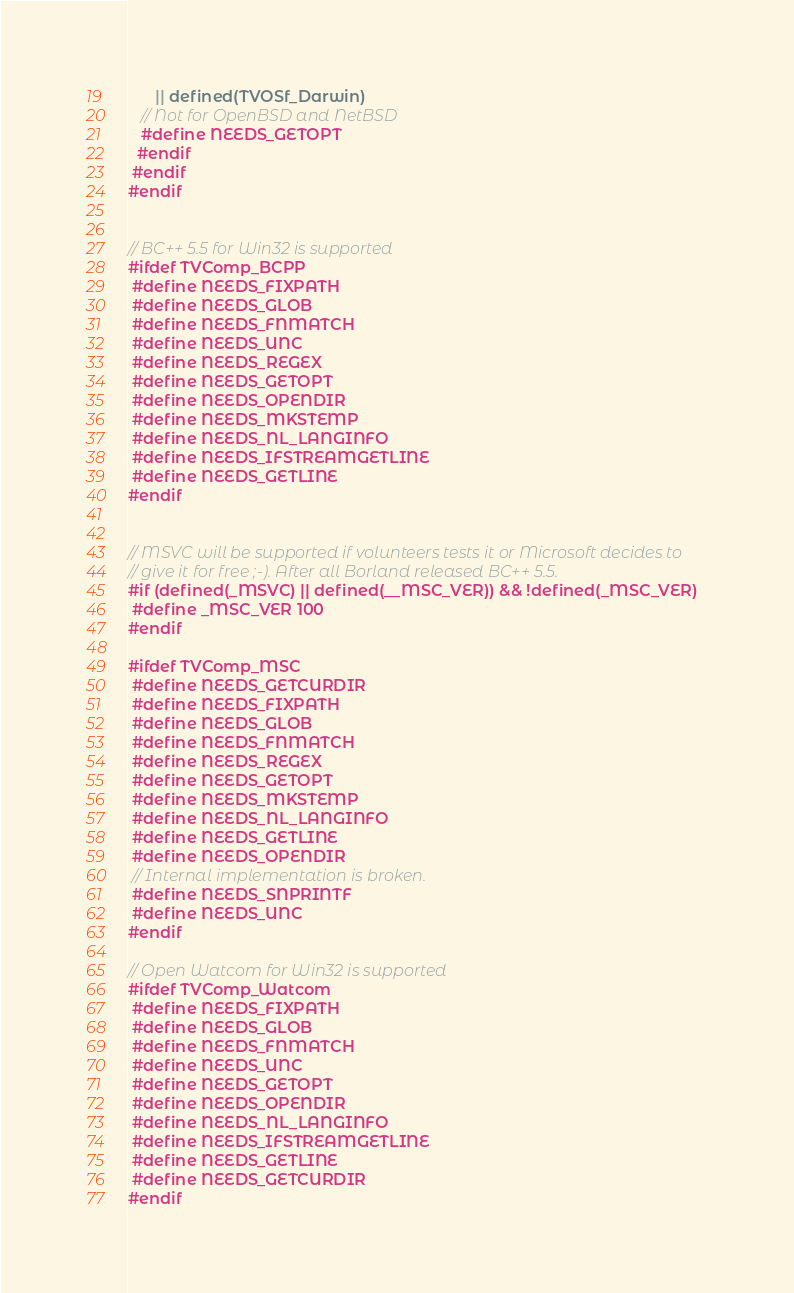Convert code to text. <code><loc_0><loc_0><loc_500><loc_500><_C_>      || defined(TVOSf_Darwin)
   // Not for OpenBSD and NetBSD
   #define NEEDS_GETOPT
  #endif
 #endif
#endif


// BC++ 5.5 for Win32 is supported
#ifdef TVComp_BCPP
 #define NEEDS_FIXPATH
 #define NEEDS_GLOB
 #define NEEDS_FNMATCH
 #define NEEDS_UNC
 #define NEEDS_REGEX
 #define NEEDS_GETOPT
 #define NEEDS_OPENDIR
 #define NEEDS_MKSTEMP
 #define NEEDS_NL_LANGINFO
 #define NEEDS_IFSTREAMGETLINE
 #define NEEDS_GETLINE
#endif


// MSVC will be supported if volunteers tests it or Microsoft decides to
// give it for free ;-). After all Borland released BC++ 5.5.
#if (defined(_MSVC) || defined(__MSC_VER)) && !defined(_MSC_VER)
 #define _MSC_VER 100
#endif

#ifdef TVComp_MSC
 #define NEEDS_GETCURDIR
 #define NEEDS_FIXPATH
 #define NEEDS_GLOB
 #define NEEDS_FNMATCH
 #define NEEDS_REGEX
 #define NEEDS_GETOPT
 #define NEEDS_MKSTEMP
 #define NEEDS_NL_LANGINFO
 #define NEEDS_GETLINE
 #define NEEDS_OPENDIR
 // Internal implementation is broken.
 #define NEEDS_SNPRINTF
 #define NEEDS_UNC
#endif

// Open Watcom for Win32 is supported
#ifdef TVComp_Watcom
 #define NEEDS_FIXPATH
 #define NEEDS_GLOB
 #define NEEDS_FNMATCH
 #define NEEDS_UNC
 #define NEEDS_GETOPT
 #define NEEDS_OPENDIR
 #define NEEDS_NL_LANGINFO
 #define NEEDS_IFSTREAMGETLINE
 #define NEEDS_GETLINE
 #define NEEDS_GETCURDIR
#endif

</code> 